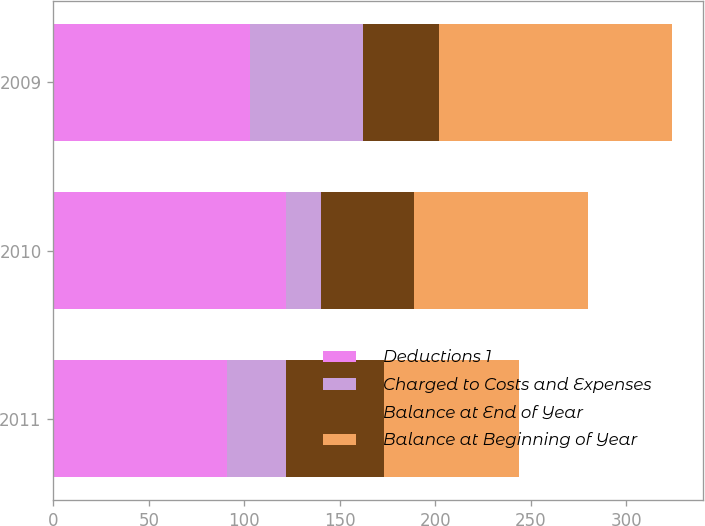Convert chart. <chart><loc_0><loc_0><loc_500><loc_500><stacked_bar_chart><ecel><fcel>2011<fcel>2010<fcel>2009<nl><fcel>Deductions 1<fcel>91<fcel>122<fcel>103<nl><fcel>Charged to Costs and Expenses<fcel>31<fcel>18<fcel>59<nl><fcel>Balance at End of Year<fcel>51<fcel>49<fcel>40<nl><fcel>Balance at Beginning of Year<fcel>71<fcel>91<fcel>122<nl></chart> 